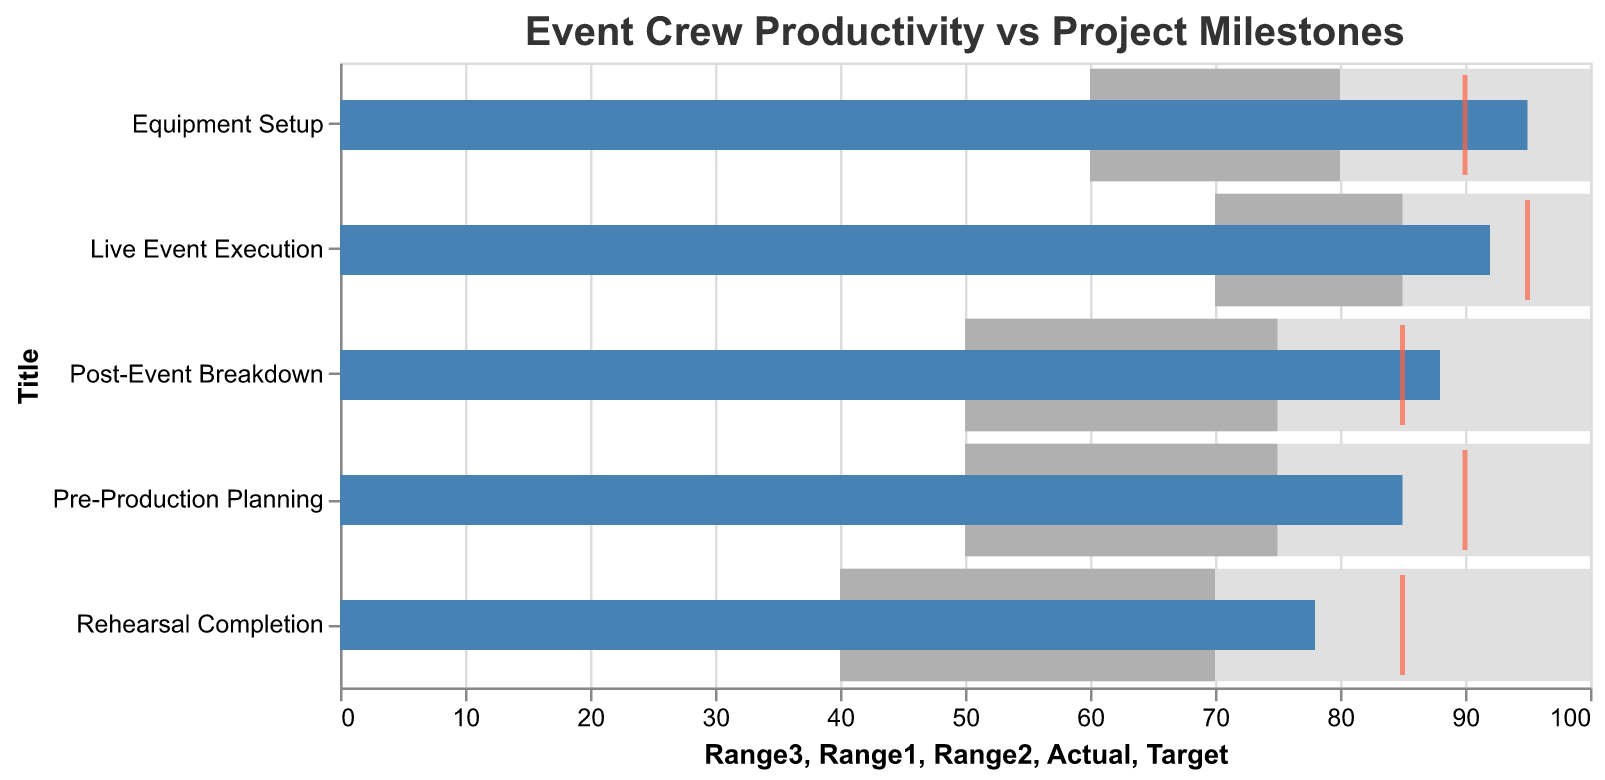What is the title of the chart? The title of the chart is positioned at the top and reads "Event Crew Productivity vs Project Milestones."
Answer: Event Crew Productivity vs Project Milestones How many project milestones are represented in the chart? By counting the number of horizontal bars, we see that there are 5 project milestones represented.
Answer: 5 What is the actual productivity level for the "Equipment Setup" milestone? By locating the "Equipment Setup" milestone on the y-axis and following the bar to the x-axis, we see the actual productivity level is 95.
Answer: 95 Which milestone has the highest actual productivity level? By checking the length of the blue bars, "Equipment Setup" has the highest actual productivity level at 95.
Answer: Equipment Setup Which milestone falls below its target productivity level? By comparing the actual (blue bar) and target (red tick) for each milestone, we can see that "Rehearsal Completion" has an actual level (78) below its target (85).
Answer: Rehearsal Completion For which milestone is the actual productivity level closest to the target? By comparing the actual levels and targets in the chart, the "Pre-Production Planning" milestone has an actual of 85 and a target of 90, making it closest with a difference of 5.
Answer: Pre-Production Planning What is the difference between the actual and target productivity levels for "Live Event Execution"? The actual level for "Live Event Execution" is 92 and the target is 95, the difference is 95 - 92 = 3.
Answer: 3 What is the average actual productivity level across all milestones? Adding all actual productivity levels (85 + 95 + 78 + 92 + 88) and dividing by 5, we get (438/5) = 87.6.
Answer: 87.6 Which milestones have achieved their highest possible productivity range? By examining the "Range3" field for each milestone, both "Equipment Setup" and "Post-Event Breakdown" have actual productivity levels equal to their maximum range (100).
Answer: Equipment Setup, Post-Event Breakdown How many milestones have actual productivity levels higher than their target levels? "Equipment Setup" (95>90), "Post-Event Breakdown" (88>85), and "Pre-Production Planning" (85>90) all have actual levels higher than their targets, which makes 3 milestones.
Answer: 3 